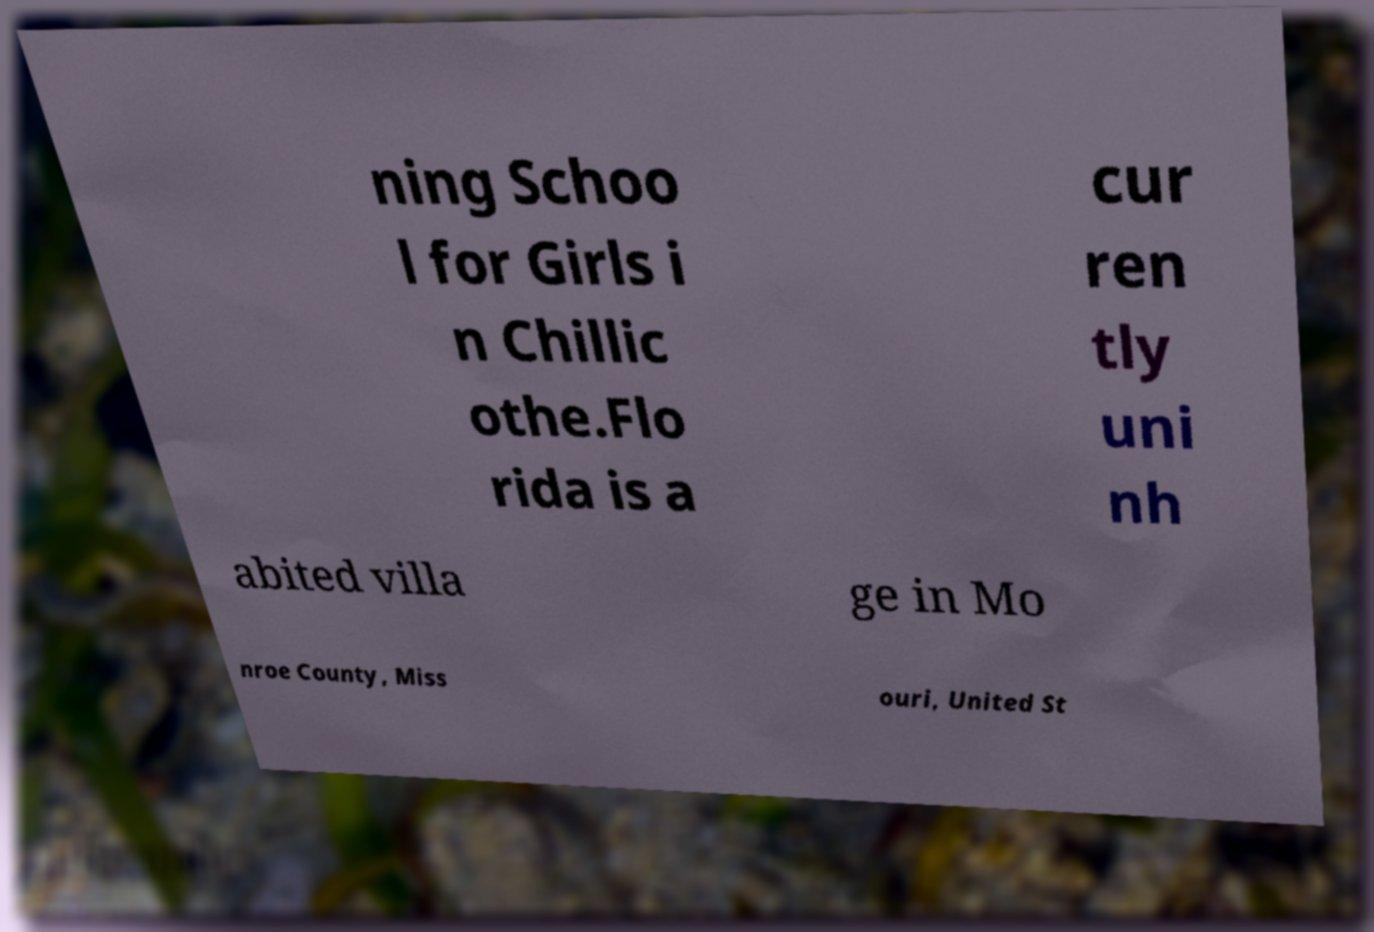Could you extract and type out the text from this image? ning Schoo l for Girls i n Chillic othe.Flo rida is a cur ren tly uni nh abited villa ge in Mo nroe County, Miss ouri, United St 